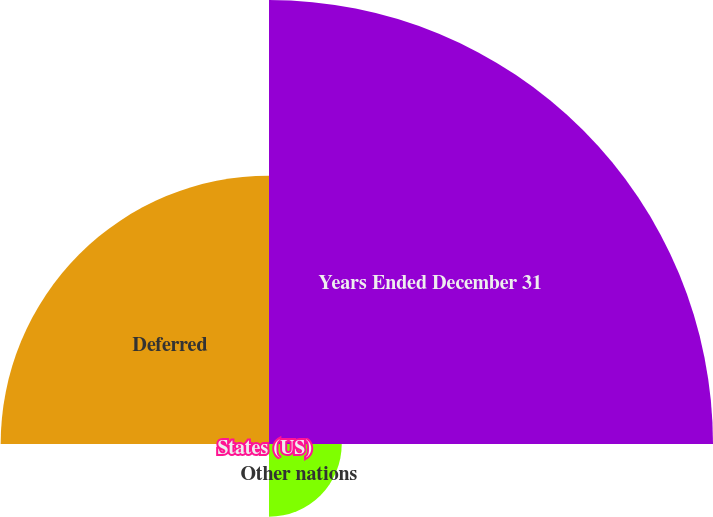Convert chart. <chart><loc_0><loc_0><loc_500><loc_500><pie_chart><fcel>Years Ended December 31<fcel>Other nations<fcel>States (US)<fcel>Deferred<nl><fcel>56.54%<fcel>9.26%<fcel>0.03%<fcel>34.17%<nl></chart> 